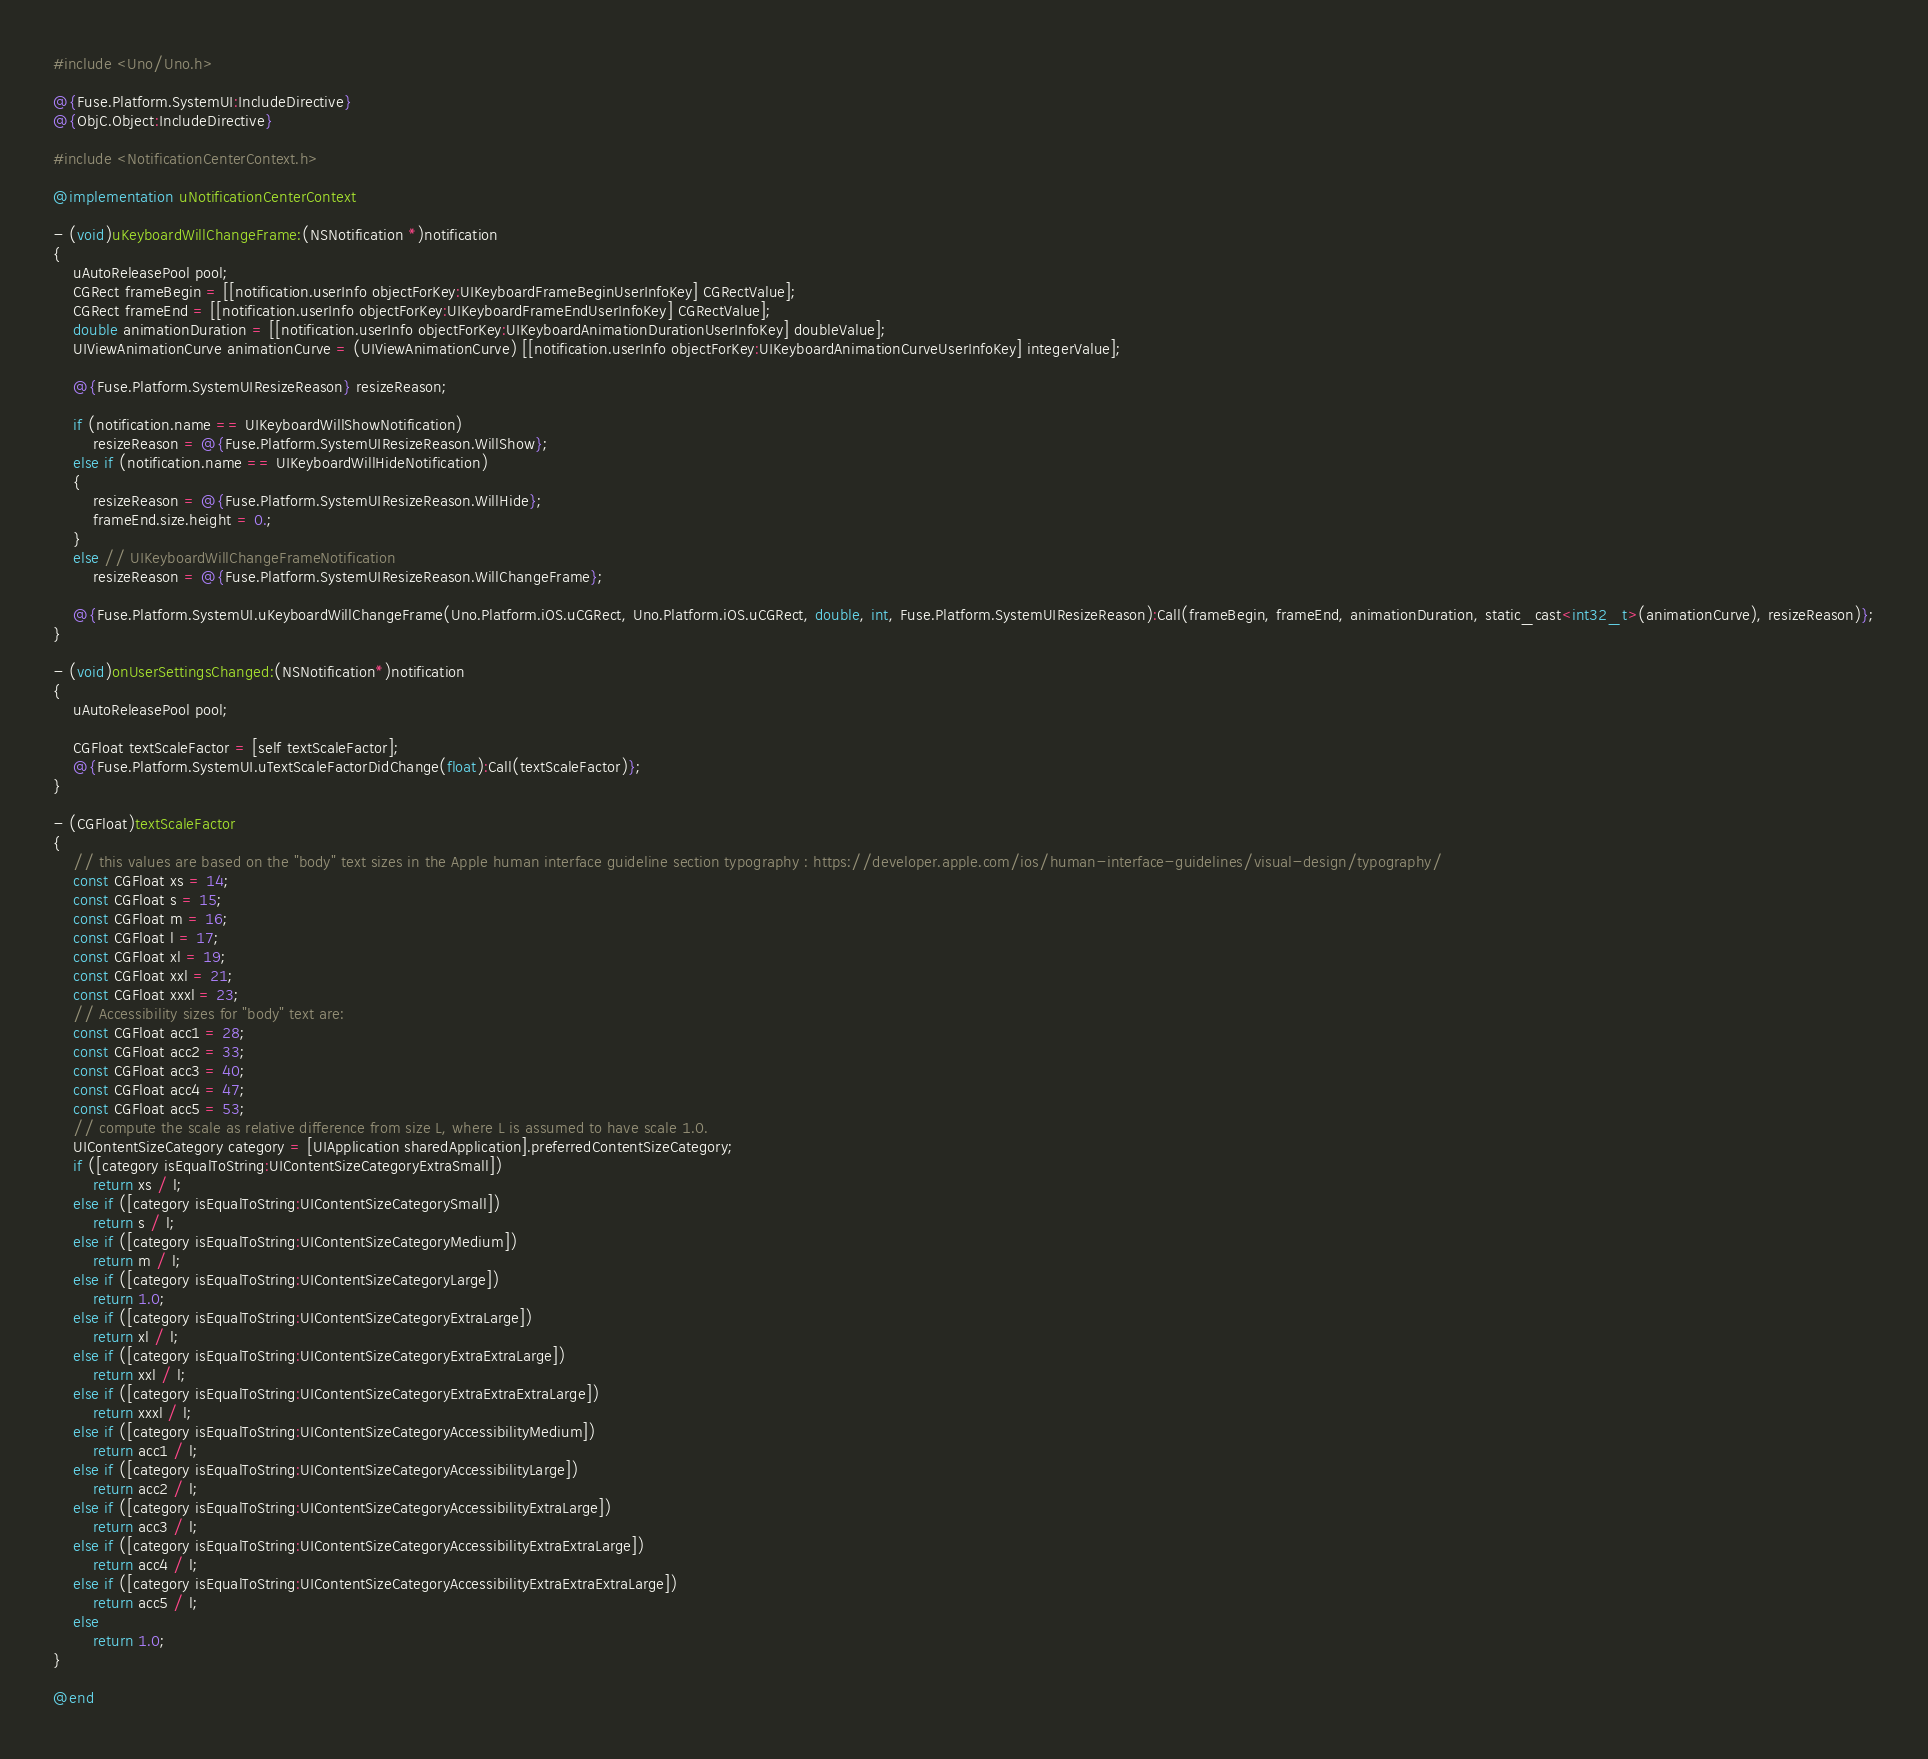Convert code to text. <code><loc_0><loc_0><loc_500><loc_500><_ObjectiveC_>#include <Uno/Uno.h>

@{Fuse.Platform.SystemUI:IncludeDirective}
@{ObjC.Object:IncludeDirective}

#include <NotificationCenterContext.h>

@implementation uNotificationCenterContext

- (void)uKeyboardWillChangeFrame:(NSNotification *)notification
{
	uAutoReleasePool pool;
	CGRect frameBegin = [[notification.userInfo objectForKey:UIKeyboardFrameBeginUserInfoKey] CGRectValue];
	CGRect frameEnd = [[notification.userInfo objectForKey:UIKeyboardFrameEndUserInfoKey] CGRectValue];
	double animationDuration = [[notification.userInfo objectForKey:UIKeyboardAnimationDurationUserInfoKey] doubleValue];
	UIViewAnimationCurve animationCurve = (UIViewAnimationCurve) [[notification.userInfo objectForKey:UIKeyboardAnimationCurveUserInfoKey] integerValue];

	@{Fuse.Platform.SystemUIResizeReason} resizeReason;

	if (notification.name == UIKeyboardWillShowNotification)
		resizeReason = @{Fuse.Platform.SystemUIResizeReason.WillShow};
	else if (notification.name == UIKeyboardWillHideNotification)
	{
		resizeReason = @{Fuse.Platform.SystemUIResizeReason.WillHide};
		frameEnd.size.height = 0.;
	}
	else // UIKeyboardWillChangeFrameNotification
		resizeReason = @{Fuse.Platform.SystemUIResizeReason.WillChangeFrame};

	@{Fuse.Platform.SystemUI.uKeyboardWillChangeFrame(Uno.Platform.iOS.uCGRect, Uno.Platform.iOS.uCGRect, double, int, Fuse.Platform.SystemUIResizeReason):Call(frameBegin, frameEnd, animationDuration, static_cast<int32_t>(animationCurve), resizeReason)};
}

- (void)onUserSettingsChanged:(NSNotification*)notification
{
	uAutoReleasePool pool;

	CGFloat textScaleFactor = [self textScaleFactor];
	@{Fuse.Platform.SystemUI.uTextScaleFactorDidChange(float):Call(textScaleFactor)};
}

- (CGFloat)textScaleFactor
{
	// this values are based on the "body" text sizes in the Apple human interface guideline section typography : https://developer.apple.com/ios/human-interface-guidelines/visual-design/typography/
	const CGFloat xs = 14;
	const CGFloat s = 15;
	const CGFloat m = 16;
	const CGFloat l = 17;
	const CGFloat xl = 19;
	const CGFloat xxl = 21;
	const CGFloat xxxl = 23;
	// Accessibility sizes for "body" text are:
	const CGFloat acc1 = 28;
  	const CGFloat acc2 = 33;
	const CGFloat acc3 = 40;
	const CGFloat acc4 = 47;
	const CGFloat acc5 = 53;
	// compute the scale as relative difference from size L, where L is assumed to have scale 1.0.
	UIContentSizeCategory category = [UIApplication sharedApplication].preferredContentSizeCategory;
	if ([category isEqualToString:UIContentSizeCategoryExtraSmall])
		return xs / l;
	else if ([category isEqualToString:UIContentSizeCategorySmall])
		return s / l;
	else if ([category isEqualToString:UIContentSizeCategoryMedium])
		return m / l;
	else if ([category isEqualToString:UIContentSizeCategoryLarge])
		return 1.0;
	else if ([category isEqualToString:UIContentSizeCategoryExtraLarge])
		return xl / l;
	else if ([category isEqualToString:UIContentSizeCategoryExtraExtraLarge])
		return xxl / l;
	else if ([category isEqualToString:UIContentSizeCategoryExtraExtraExtraLarge])
		return xxxl / l;
	else if ([category isEqualToString:UIContentSizeCategoryAccessibilityMedium])
		return acc1 / l;
	else if ([category isEqualToString:UIContentSizeCategoryAccessibilityLarge])
		return acc2 / l;
	else if ([category isEqualToString:UIContentSizeCategoryAccessibilityExtraLarge])
		return acc3 / l;
	else if ([category isEqualToString:UIContentSizeCategoryAccessibilityExtraExtraLarge])
		return acc4 / l;
	else if ([category isEqualToString:UIContentSizeCategoryAccessibilityExtraExtraExtraLarge])
		return acc5 / l;
	else
		return 1.0;
}

@end
</code> 